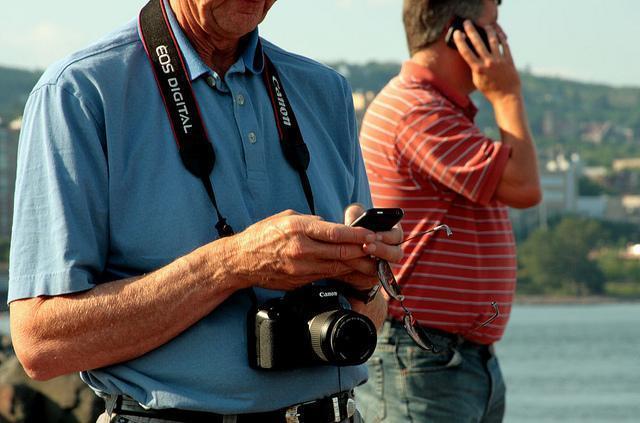How many men are there?
Give a very brief answer. 2. How many people can be seen?
Give a very brief answer. 2. 